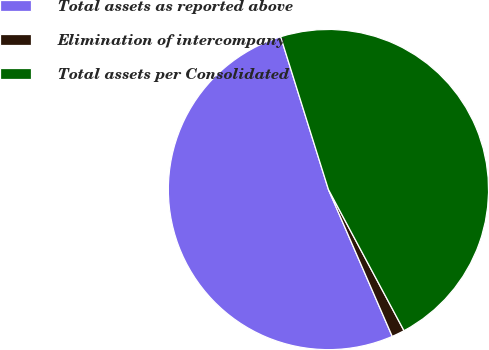Convert chart. <chart><loc_0><loc_0><loc_500><loc_500><pie_chart><fcel>Total assets as reported above<fcel>Elimination of intercompany<fcel>Total assets per Consolidated<nl><fcel>51.7%<fcel>1.3%<fcel>47.0%<nl></chart> 